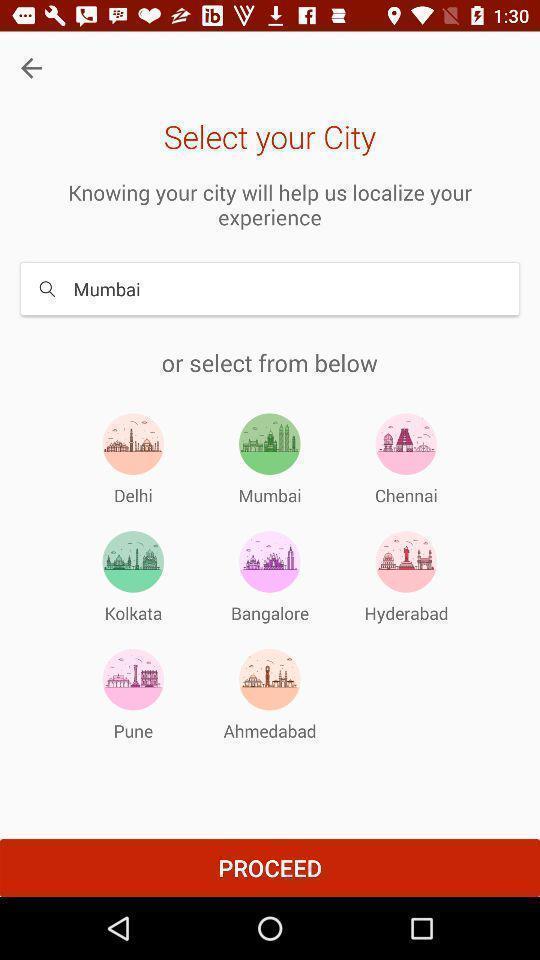Tell me about the visual elements in this screen capture. Search page. 